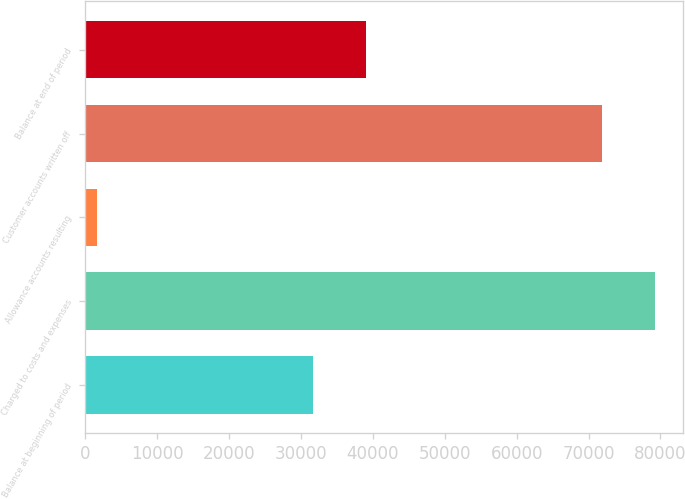Convert chart. <chart><loc_0><loc_0><loc_500><loc_500><bar_chart><fcel>Balance at beginning of period<fcel>Charged to costs and expenses<fcel>Allowance accounts resulting<fcel>Customer accounts written off<fcel>Balance at end of period<nl><fcel>31730<fcel>79182.1<fcel>1587<fcel>71877<fcel>39035.1<nl></chart> 